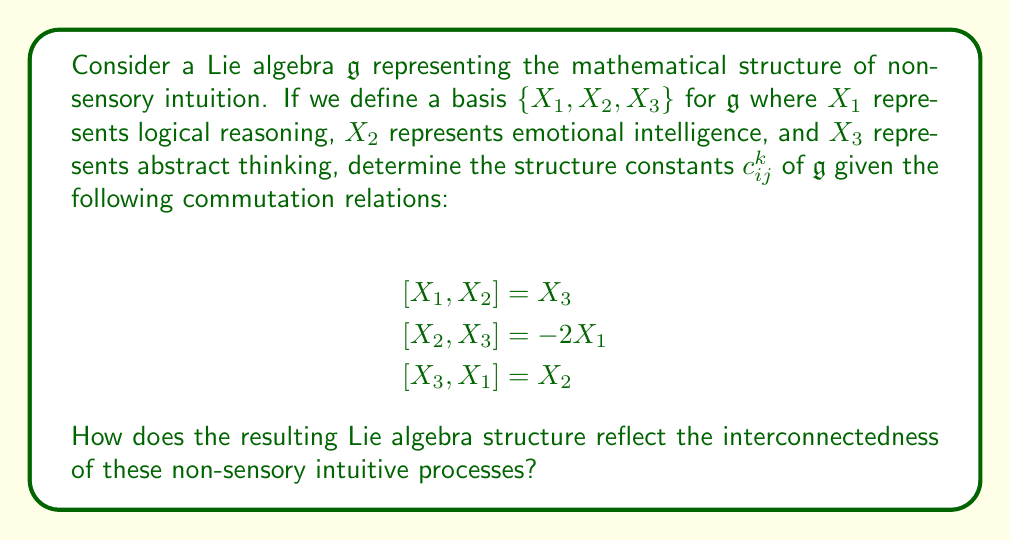What is the answer to this math problem? To solve this problem, we need to understand the concept of structure constants in Lie algebras and how they relate to the commutation relations between basis elements.

1) In a Lie algebra, the commutator of two basis elements can be expressed as a linear combination of the basis elements:

   $$[X_i, X_j] = \sum_k c_{ij}^k X_k$$

   where $c_{ij}^k$ are the structure constants.

2) From the given commutation relations, we can identify the structure constants:

   For $[X_1, X_2] = X_3$:
   $c_{12}^3 = 1$, all other $c_{12}^k = 0$

   For $[X_2, X_3] = -2X_1$:
   $c_{23}^1 = -2$, all other $c_{23}^k = 0$

   For $[X_3, X_1] = X_2$:
   $c_{31}^2 = 1$, all other $c_{31}^k = 0$

3) The structure constants have the following properties:
   - $c_{ij}^k = -c_{ji}^k$ (antisymmetry)
   - $c_{ij}^k + c_{jk}^i + c_{ki}^j = 0$ (Jacobi identity)

4) The resulting Lie algebra structure reflects the interconnectedness of non-sensory intuitive processes in several ways:

   a) The non-zero structure constants indicate that these processes are not independent but interact with each other.

   b) The antisymmetry of the structure constants (e.g., $c_{12}^3 = -c_{21}^3$) suggests that the interaction between two processes has opposite effects when considered in reverse order.

   c) The Jacobi identity ensures the consistency of these interactions in a way that preserves the overall structure of the intuitive processes.

   d) The specific values of the structure constants suggest varying strengths of interactions. For example, the interaction between emotional intelligence and abstract thinking ($[X_2, X_3]$) has a stronger effect on logical reasoning than other interactions.

This mathematical model using Lie algebras provides a framework for understanding how different aspects of non-sensory intuition might interact and influence each other in a structured, consistent manner that transcends direct sensory perception.
Answer: The structure constants of the Lie algebra $\mathfrak{g}$ are:

$c_{12}^3 = 1$, $c_{23}^1 = -2$, $c_{31}^2 = 1$

All other $c_{ij}^k = 0$ or can be derived from these using the antisymmetry property.

This Lie algebra structure reflects the interconnectedness of non-sensory intuitive processes through non-zero structure constants, antisymmetry, the Jacobi identity, and varying interaction strengths, providing a mathematical framework for understanding intuition beyond sensory perception. 